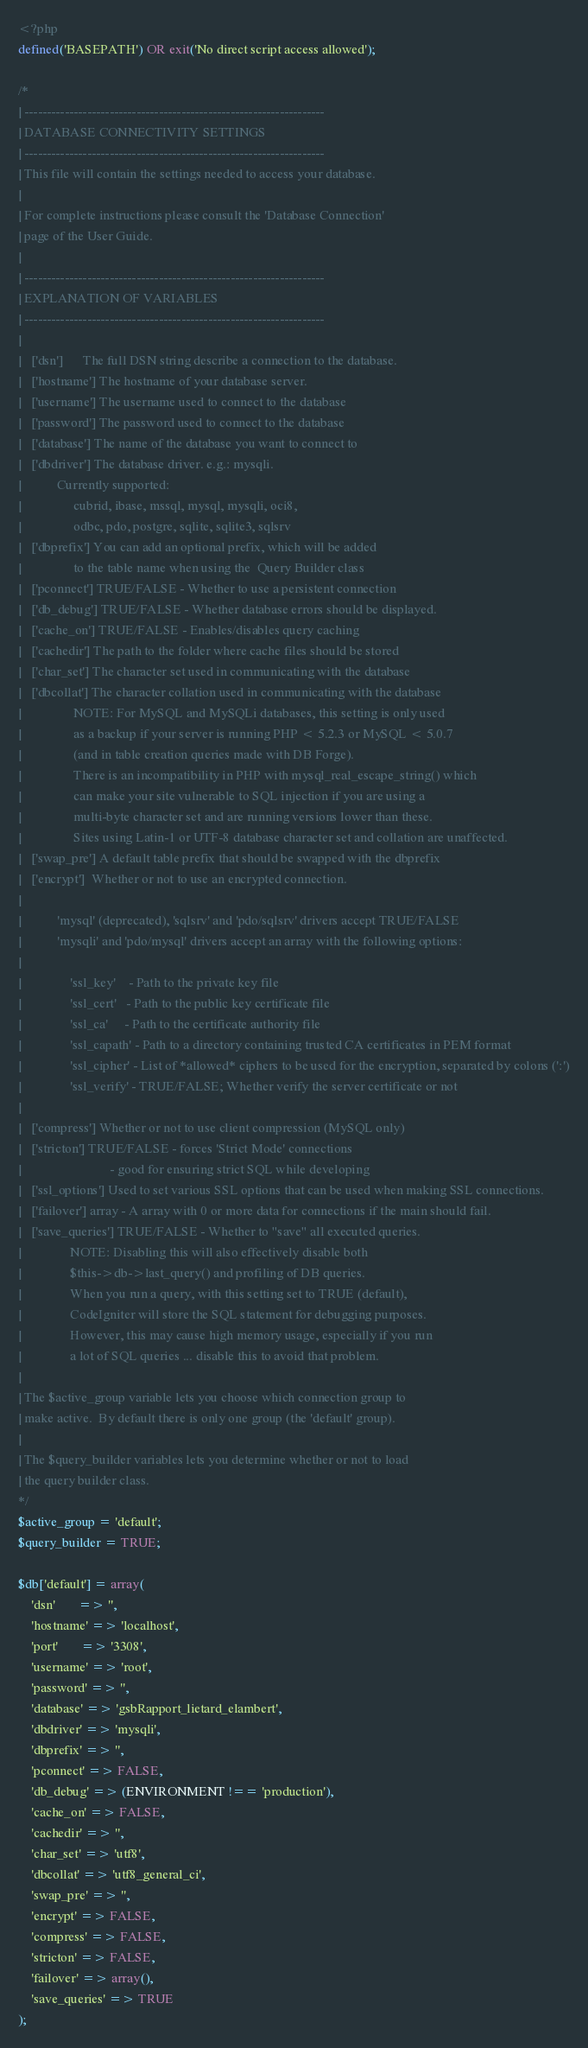<code> <loc_0><loc_0><loc_500><loc_500><_PHP_><?php
defined('BASEPATH') OR exit('No direct script access allowed');

/*
| -------------------------------------------------------------------
| DATABASE CONNECTIVITY SETTINGS
| -------------------------------------------------------------------
| This file will contain the settings needed to access your database.
|
| For complete instructions please consult the 'Database Connection'
| page of the User Guide.
|
| -------------------------------------------------------------------
| EXPLANATION OF VARIABLES
| -------------------------------------------------------------------
|
|	['dsn']      The full DSN string describe a connection to the database.
|	['hostname'] The hostname of your database server.
|	['username'] The username used to connect to the database
|	['password'] The password used to connect to the database
|	['database'] The name of the database you want to connect to
|	['dbdriver'] The database driver. e.g.: mysqli.
|			Currently supported:
|				 cubrid, ibase, mssql, mysql, mysqli, oci8,
|				 odbc, pdo, postgre, sqlite, sqlite3, sqlsrv
|	['dbprefix'] You can add an optional prefix, which will be added
|				 to the table name when using the  Query Builder class
|	['pconnect'] TRUE/FALSE - Whether to use a persistent connection
|	['db_debug'] TRUE/FALSE - Whether database errors should be displayed.
|	['cache_on'] TRUE/FALSE - Enables/disables query caching
|	['cachedir'] The path to the folder where cache files should be stored
|	['char_set'] The character set used in communicating with the database
|	['dbcollat'] The character collation used in communicating with the database
|				 NOTE: For MySQL and MySQLi databases, this setting is only used
| 				 as a backup if your server is running PHP < 5.2.3 or MySQL < 5.0.7
|				 (and in table creation queries made with DB Forge).
| 				 There is an incompatibility in PHP with mysql_real_escape_string() which
| 				 can make your site vulnerable to SQL injection if you are using a
| 				 multi-byte character set and are running versions lower than these.
| 				 Sites using Latin-1 or UTF-8 database character set and collation are unaffected.
|	['swap_pre'] A default table prefix that should be swapped with the dbprefix
|	['encrypt']  Whether or not to use an encrypted connection.
|
|			'mysql' (deprecated), 'sqlsrv' and 'pdo/sqlsrv' drivers accept TRUE/FALSE
|			'mysqli' and 'pdo/mysql' drivers accept an array with the following options:
|
|				'ssl_key'    - Path to the private key file
|				'ssl_cert'   - Path to the public key certificate file
|				'ssl_ca'     - Path to the certificate authority file
|				'ssl_capath' - Path to a directory containing trusted CA certificates in PEM format
|				'ssl_cipher' - List of *allowed* ciphers to be used for the encryption, separated by colons (':')
|				'ssl_verify' - TRUE/FALSE; Whether verify the server certificate or not
|
|	['compress'] Whether or not to use client compression (MySQL only)
|	['stricton'] TRUE/FALSE - forces 'Strict Mode' connections
|							- good for ensuring strict SQL while developing
|	['ssl_options']	Used to set various SSL options that can be used when making SSL connections.
|	['failover'] array - A array with 0 or more data for connections if the main should fail.
|	['save_queries'] TRUE/FALSE - Whether to "save" all executed queries.
| 				NOTE: Disabling this will also effectively disable both
| 				$this->db->last_query() and profiling of DB queries.
| 				When you run a query, with this setting set to TRUE (default),
| 				CodeIgniter will store the SQL statement for debugging purposes.
| 				However, this may cause high memory usage, especially if you run
| 				a lot of SQL queries ... disable this to avoid that problem.
|
| The $active_group variable lets you choose which connection group to
| make active.  By default there is only one group (the 'default' group).
|
| The $query_builder variables lets you determine whether or not to load
| the query builder class.
*/
$active_group = 'default';
$query_builder = TRUE;

$db['default'] = array(
	'dsn'	   => '',
	'hostname' => 'localhost',
	'port'	   => '3308',
	'username' => 'root',
	'password' => '',
	'database' => 'gsbRapport_lietard_elambert',
	'dbdriver' => 'mysqli',
	'dbprefix' => '',
	'pconnect' => FALSE,
	'db_debug' => (ENVIRONMENT !== 'production'),
	'cache_on' => FALSE,
	'cachedir' => '',
	'char_set' => 'utf8',
	'dbcollat' => 'utf8_general_ci',
	'swap_pre' => '',
	'encrypt' => FALSE,
	'compress' => FALSE,
	'stricton' => FALSE,
	'failover' => array(),
	'save_queries' => TRUE
);
</code> 